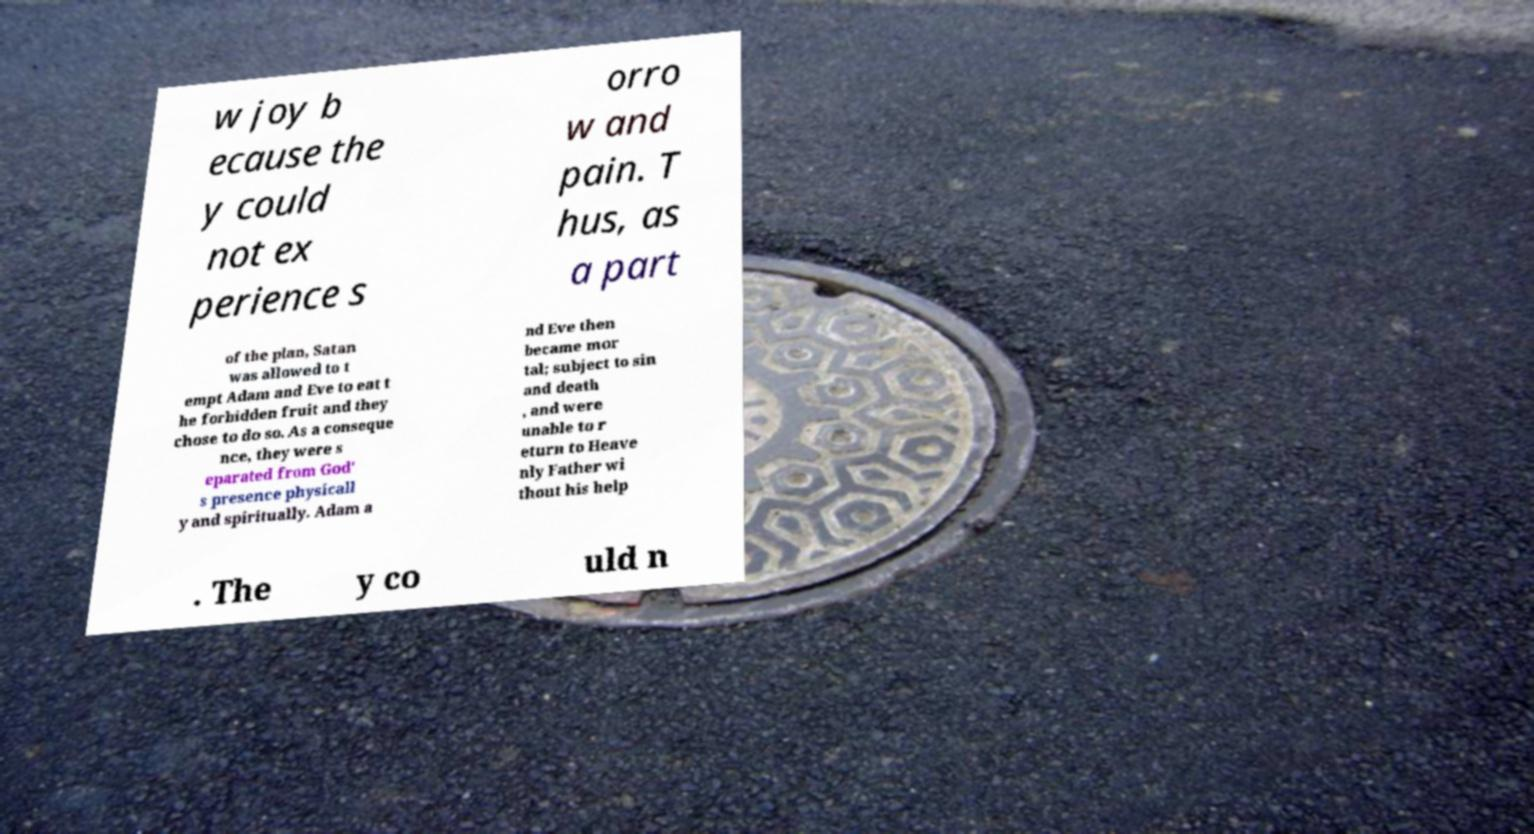There's text embedded in this image that I need extracted. Can you transcribe it verbatim? w joy b ecause the y could not ex perience s orro w and pain. T hus, as a part of the plan, Satan was allowed to t empt Adam and Eve to eat t he forbidden fruit and they chose to do so. As a conseque nce, they were s eparated from God' s presence physicall y and spiritually. Adam a nd Eve then became mor tal; subject to sin and death , and were unable to r eturn to Heave nly Father wi thout his help . The y co uld n 